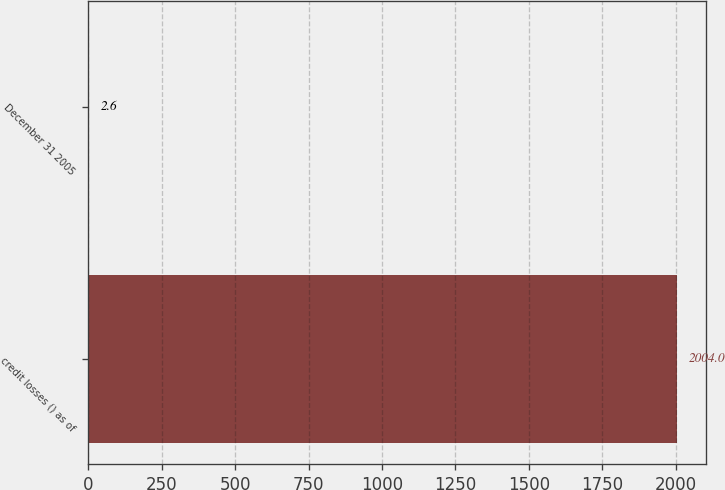Convert chart to OTSL. <chart><loc_0><loc_0><loc_500><loc_500><bar_chart><fcel>credit losses () as of<fcel>December 31 2005<nl><fcel>2004<fcel>2.6<nl></chart> 